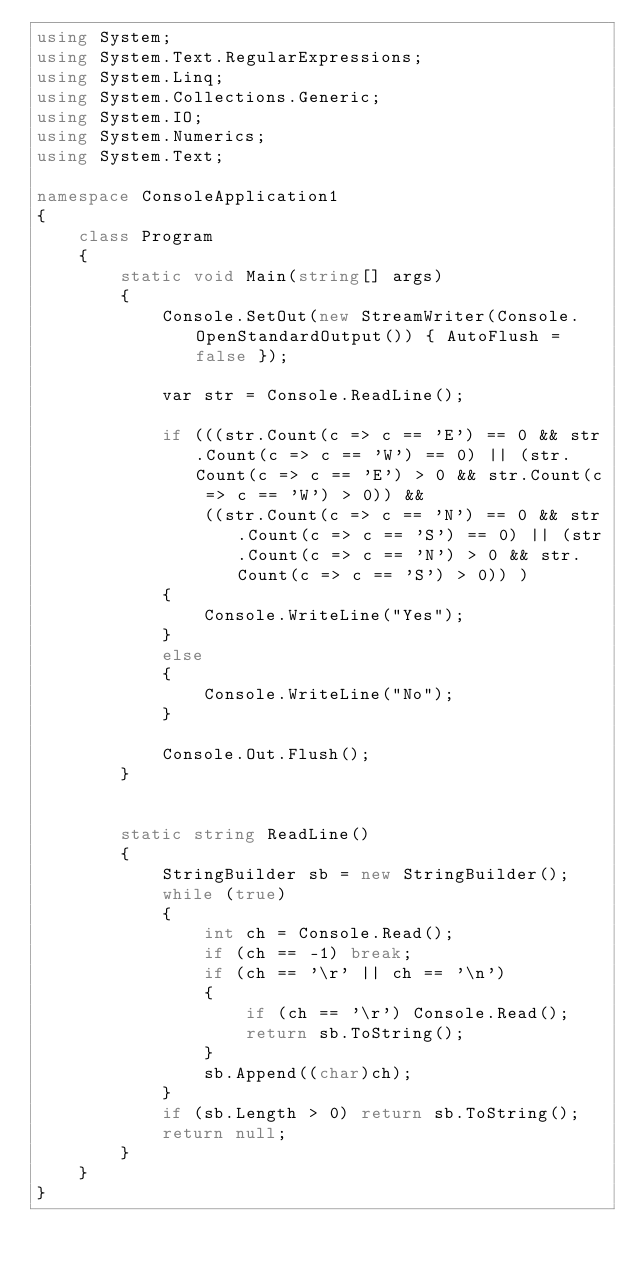Convert code to text. <code><loc_0><loc_0><loc_500><loc_500><_C#_>using System;
using System.Text.RegularExpressions;
using System.Linq;
using System.Collections.Generic;
using System.IO;
using System.Numerics;
using System.Text;

namespace ConsoleApplication1
{
    class Program
    {
        static void Main(string[] args)
        {
            Console.SetOut(new StreamWriter(Console.OpenStandardOutput()) { AutoFlush = false });

            var str = Console.ReadLine();

            if (((str.Count(c => c == 'E') == 0 && str.Count(c => c == 'W') == 0) || (str.Count(c => c == 'E') > 0 && str.Count(c => c == 'W') > 0)) &&
                ((str.Count(c => c == 'N') == 0 && str.Count(c => c == 'S') == 0) || (str.Count(c => c == 'N') > 0 && str.Count(c => c == 'S') > 0)) )
            {
                Console.WriteLine("Yes");
            }
            else
            {
                Console.WriteLine("No");
            }

            Console.Out.Flush();
        }


        static string ReadLine()
        {
            StringBuilder sb = new StringBuilder();
            while (true)
            {
                int ch = Console.Read();
                if (ch == -1) break;
                if (ch == '\r' || ch == '\n')
                {
                    if (ch == '\r') Console.Read();
                    return sb.ToString();
                }
                sb.Append((char)ch);
            }
            if (sb.Length > 0) return sb.ToString();
            return null;
        } 
    }
}</code> 